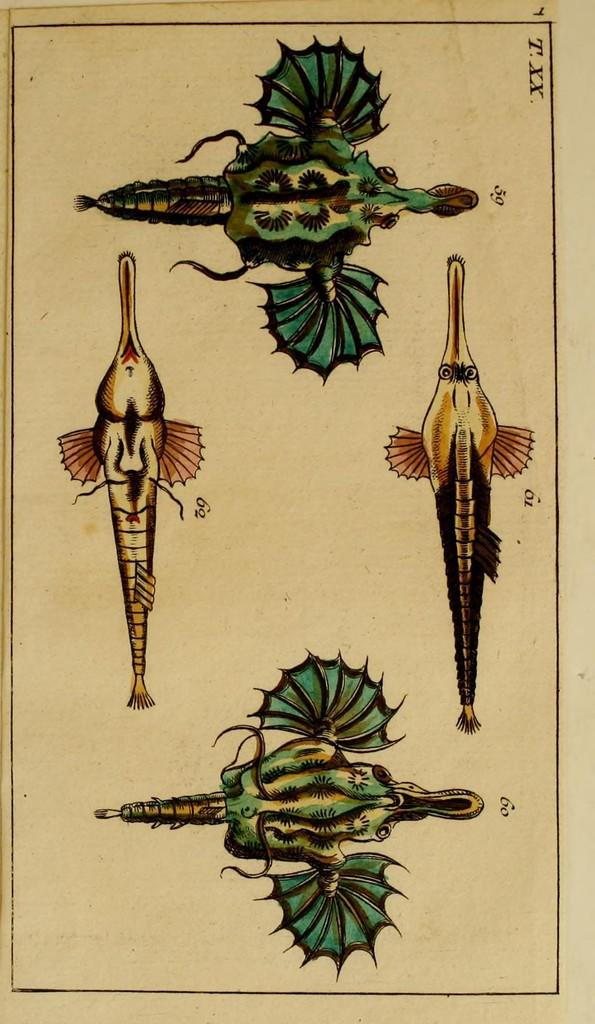What type of artwork is featured in the image? There are paintings of animals in the image. How many animal paintings can be seen in total? There are four images of animals in total. How many hands are visible in the image? There are no hands visible in the image, as it only features paintings of animals. 